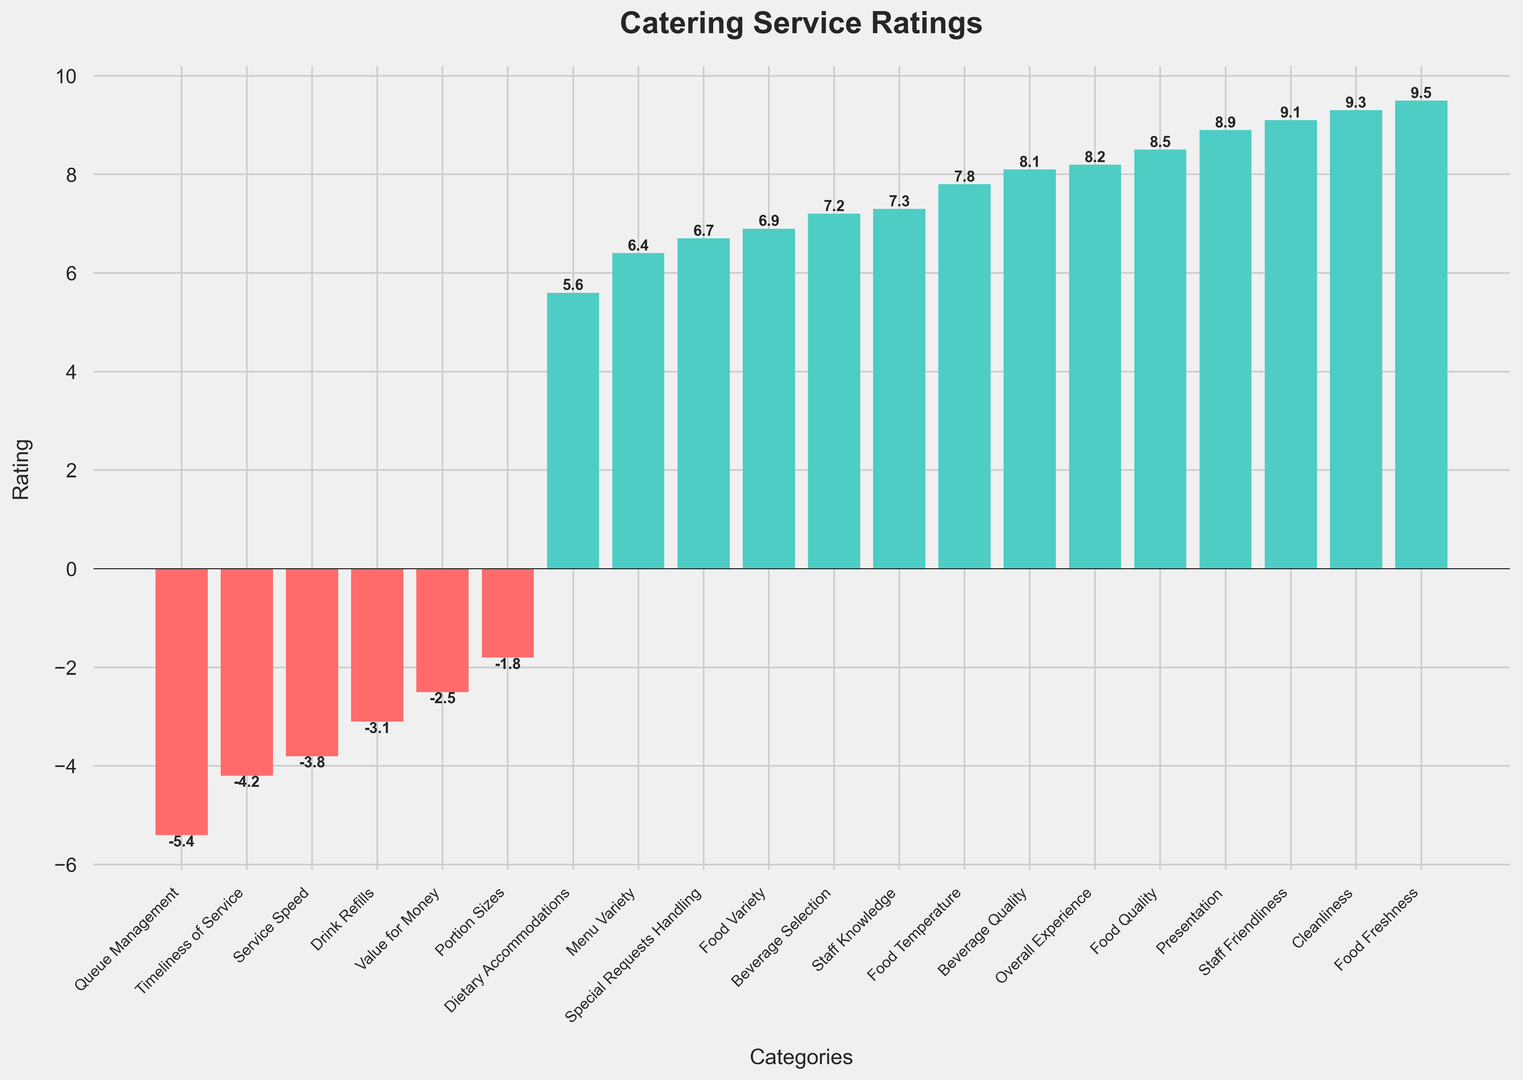Which category received the highest rating? By looking at the height of the bars, the "Food Freshness" category goes the highest above the zero line, indicating it received the highest rating.
Answer: Food Freshness Which category has the lowest rating? By identifying the bar that extends the farthest below the zero line, "Queue Management" is the category with the lowest rating.
Answer: Queue Management How many categories have negative ratings? By counting the number of bars that are below the zero line, there are 7 categories with negative ratings.
Answer: 7 Which categories have ratings greater than 8.0? By observing the bars that extend above the 8.0 mark, the categories are "Food Freshness", "Cleanliness", "Staff Friendliness", "Presentation", "Food Quality", and "Overall Experience".
Answer: Food Freshness, Cleanliness, Staff Friendliness, Presentation, Food Quality, Overall Experience What is the difference in rating between "Food Quality" and "Service Speed"? The rating for "Food Quality" is 8.5 and for "Service Speed" is -3.8. The difference is 8.5 - (-3.8) = 8.5 + 3.8 = 12.3.
Answer: 12.3 Are there more categories with ratings above zero than below zero? There are 13 categories with positive ratings and 7 categories with negative ratings, so yes, there are more categories above zero.
Answer: Yes Which categories have ratings between 7.0 and 8.0? By identifying bars that fall within this range, the categories are "Beverage Selection", "Staff Knowledge", "Food Temperature", and "Beverage Quality".
Answer: Beverage Selection, Staff Knowledge, Food Temperature, Beverage Quality What is the average rating of categories with positive values? The sum of the positive ratings is 8.5 + 7.2 + 9.1 + 6.4 + 8.9 + 5.6 + 9.3 + 7.8 + 6.7 + 8.2 + 9.5 + 8.1 + 7.3 + 6.9 = 109.5. There are 13 categories. The average is 109.5 / 13 = 8.42.
Answer: 8.42 Which categories are closer to a rating of zero? By observing the bars that are very close to the zero line, "Portion Sizes" with -1.8 and "Value for Money" with -2.5 are closest.
Answer: Portion Sizes, Value for Money What is the sum of ratings for categories related to staff attributes (Staff Friendliness, Staff Knowledge)? The rating for "Staff Friendliness" is 9.1, and for "Staff Knowledge" is 7.3. The sum is 9.1 + 7.3 = 16.4.
Answer: 16.4 